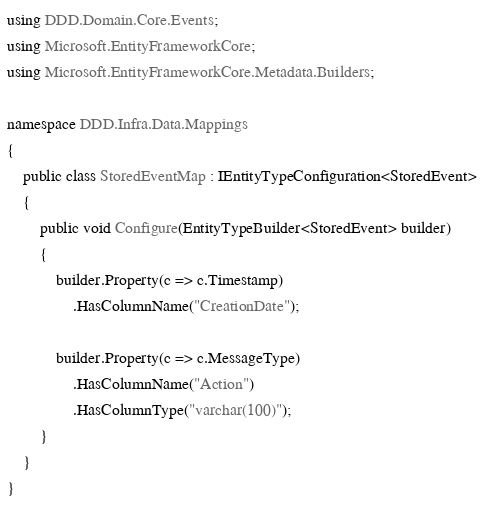Convert code to text. <code><loc_0><loc_0><loc_500><loc_500><_C#_>using DDD.Domain.Core.Events;
using Microsoft.EntityFrameworkCore;
using Microsoft.EntityFrameworkCore.Metadata.Builders;

namespace DDD.Infra.Data.Mappings
{
    public class StoredEventMap : IEntityTypeConfiguration<StoredEvent>
    {
        public void Configure(EntityTypeBuilder<StoredEvent> builder)
        {
            builder.Property(c => c.Timestamp)
                .HasColumnName("CreationDate");

            builder.Property(c => c.MessageType)
                .HasColumnName("Action")
                .HasColumnType("varchar(100)");
        }
    }
}
</code> 